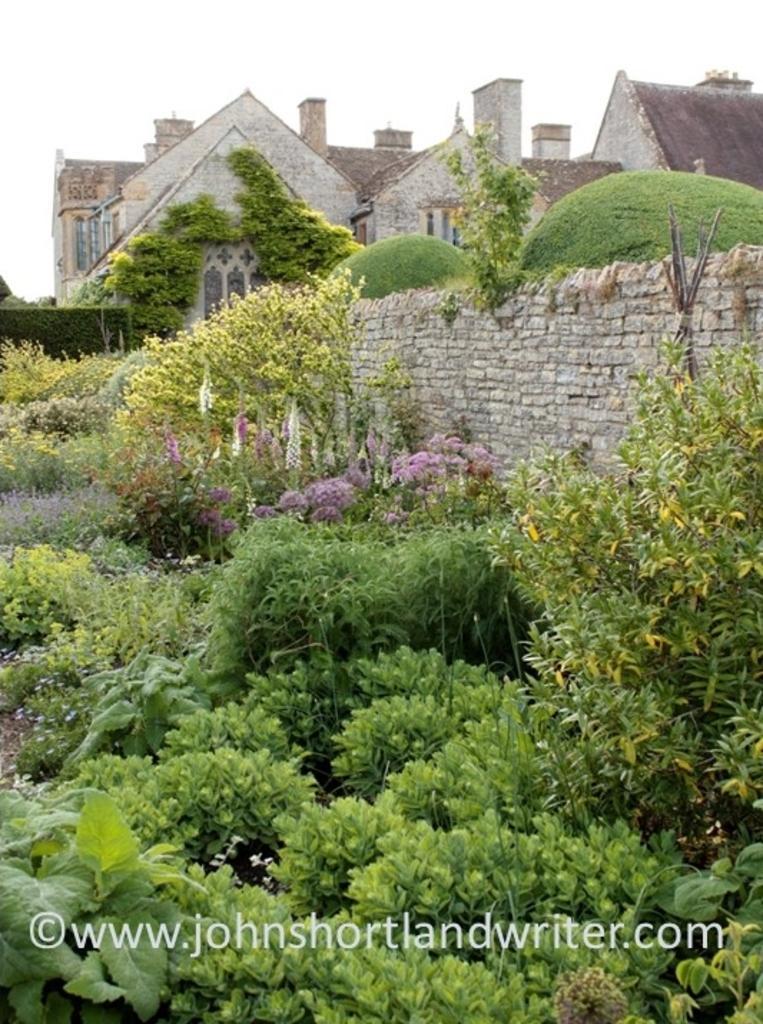Please provide a concise description of this image. In this image I can see number of green colour plants, a building and here I can see watermark. 